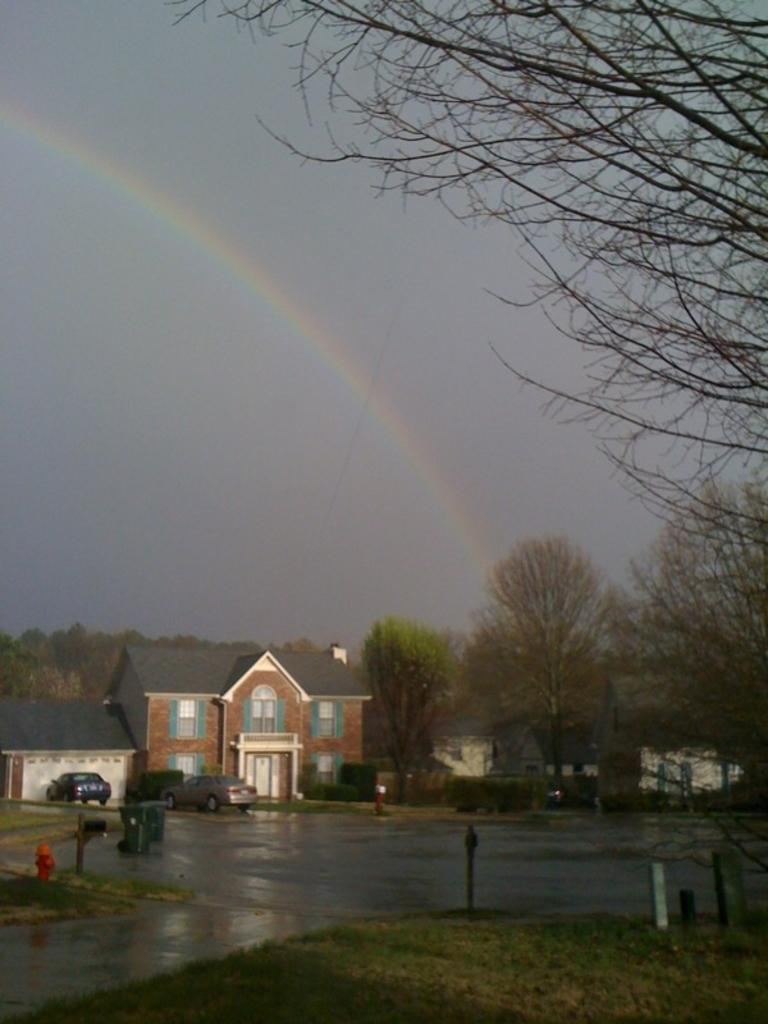What is the main structure in the image? There is a building in the image. What is located in front of the building? There are two vehicles in front of the building. What can be seen in the background of the image? There are trees and a rainbow visible in the background of the image. Where is the tub located in the image? There is no tub present in the image. What type of spade is being used by the person in the image? There is no person or spade present in the image. 